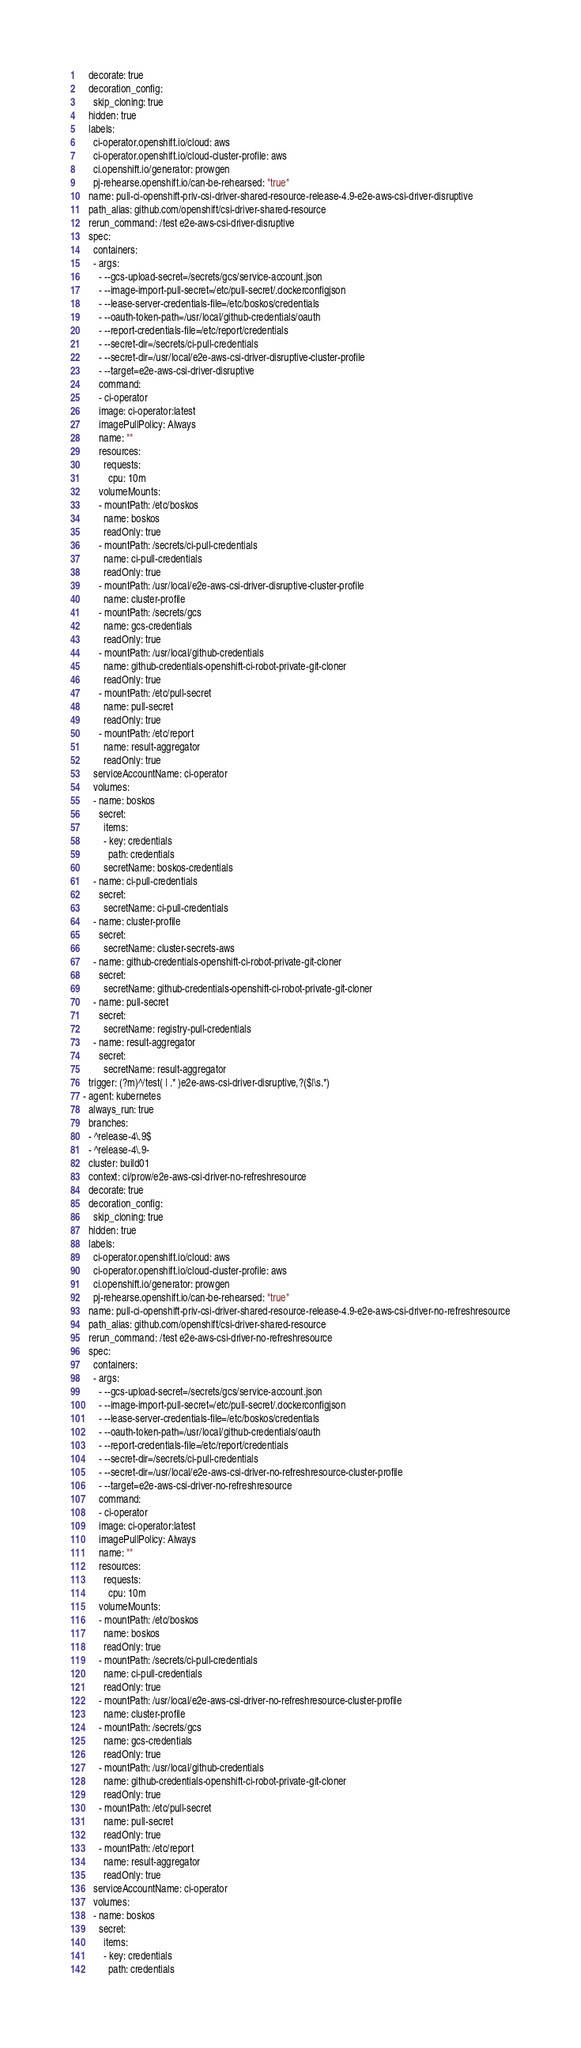<code> <loc_0><loc_0><loc_500><loc_500><_YAML_>    decorate: true
    decoration_config:
      skip_cloning: true
    hidden: true
    labels:
      ci-operator.openshift.io/cloud: aws
      ci-operator.openshift.io/cloud-cluster-profile: aws
      ci.openshift.io/generator: prowgen
      pj-rehearse.openshift.io/can-be-rehearsed: "true"
    name: pull-ci-openshift-priv-csi-driver-shared-resource-release-4.9-e2e-aws-csi-driver-disruptive
    path_alias: github.com/openshift/csi-driver-shared-resource
    rerun_command: /test e2e-aws-csi-driver-disruptive
    spec:
      containers:
      - args:
        - --gcs-upload-secret=/secrets/gcs/service-account.json
        - --image-import-pull-secret=/etc/pull-secret/.dockerconfigjson
        - --lease-server-credentials-file=/etc/boskos/credentials
        - --oauth-token-path=/usr/local/github-credentials/oauth
        - --report-credentials-file=/etc/report/credentials
        - --secret-dir=/secrets/ci-pull-credentials
        - --secret-dir=/usr/local/e2e-aws-csi-driver-disruptive-cluster-profile
        - --target=e2e-aws-csi-driver-disruptive
        command:
        - ci-operator
        image: ci-operator:latest
        imagePullPolicy: Always
        name: ""
        resources:
          requests:
            cpu: 10m
        volumeMounts:
        - mountPath: /etc/boskos
          name: boskos
          readOnly: true
        - mountPath: /secrets/ci-pull-credentials
          name: ci-pull-credentials
          readOnly: true
        - mountPath: /usr/local/e2e-aws-csi-driver-disruptive-cluster-profile
          name: cluster-profile
        - mountPath: /secrets/gcs
          name: gcs-credentials
          readOnly: true
        - mountPath: /usr/local/github-credentials
          name: github-credentials-openshift-ci-robot-private-git-cloner
          readOnly: true
        - mountPath: /etc/pull-secret
          name: pull-secret
          readOnly: true
        - mountPath: /etc/report
          name: result-aggregator
          readOnly: true
      serviceAccountName: ci-operator
      volumes:
      - name: boskos
        secret:
          items:
          - key: credentials
            path: credentials
          secretName: boskos-credentials
      - name: ci-pull-credentials
        secret:
          secretName: ci-pull-credentials
      - name: cluster-profile
        secret:
          secretName: cluster-secrets-aws
      - name: github-credentials-openshift-ci-robot-private-git-cloner
        secret:
          secretName: github-credentials-openshift-ci-robot-private-git-cloner
      - name: pull-secret
        secret:
          secretName: registry-pull-credentials
      - name: result-aggregator
        secret:
          secretName: result-aggregator
    trigger: (?m)^/test( | .* )e2e-aws-csi-driver-disruptive,?($|\s.*)
  - agent: kubernetes
    always_run: true
    branches:
    - ^release-4\.9$
    - ^release-4\.9-
    cluster: build01
    context: ci/prow/e2e-aws-csi-driver-no-refreshresource
    decorate: true
    decoration_config:
      skip_cloning: true
    hidden: true
    labels:
      ci-operator.openshift.io/cloud: aws
      ci-operator.openshift.io/cloud-cluster-profile: aws
      ci.openshift.io/generator: prowgen
      pj-rehearse.openshift.io/can-be-rehearsed: "true"
    name: pull-ci-openshift-priv-csi-driver-shared-resource-release-4.9-e2e-aws-csi-driver-no-refreshresource
    path_alias: github.com/openshift/csi-driver-shared-resource
    rerun_command: /test e2e-aws-csi-driver-no-refreshresource
    spec:
      containers:
      - args:
        - --gcs-upload-secret=/secrets/gcs/service-account.json
        - --image-import-pull-secret=/etc/pull-secret/.dockerconfigjson
        - --lease-server-credentials-file=/etc/boskos/credentials
        - --oauth-token-path=/usr/local/github-credentials/oauth
        - --report-credentials-file=/etc/report/credentials
        - --secret-dir=/secrets/ci-pull-credentials
        - --secret-dir=/usr/local/e2e-aws-csi-driver-no-refreshresource-cluster-profile
        - --target=e2e-aws-csi-driver-no-refreshresource
        command:
        - ci-operator
        image: ci-operator:latest
        imagePullPolicy: Always
        name: ""
        resources:
          requests:
            cpu: 10m
        volumeMounts:
        - mountPath: /etc/boskos
          name: boskos
          readOnly: true
        - mountPath: /secrets/ci-pull-credentials
          name: ci-pull-credentials
          readOnly: true
        - mountPath: /usr/local/e2e-aws-csi-driver-no-refreshresource-cluster-profile
          name: cluster-profile
        - mountPath: /secrets/gcs
          name: gcs-credentials
          readOnly: true
        - mountPath: /usr/local/github-credentials
          name: github-credentials-openshift-ci-robot-private-git-cloner
          readOnly: true
        - mountPath: /etc/pull-secret
          name: pull-secret
          readOnly: true
        - mountPath: /etc/report
          name: result-aggregator
          readOnly: true
      serviceAccountName: ci-operator
      volumes:
      - name: boskos
        secret:
          items:
          - key: credentials
            path: credentials</code> 